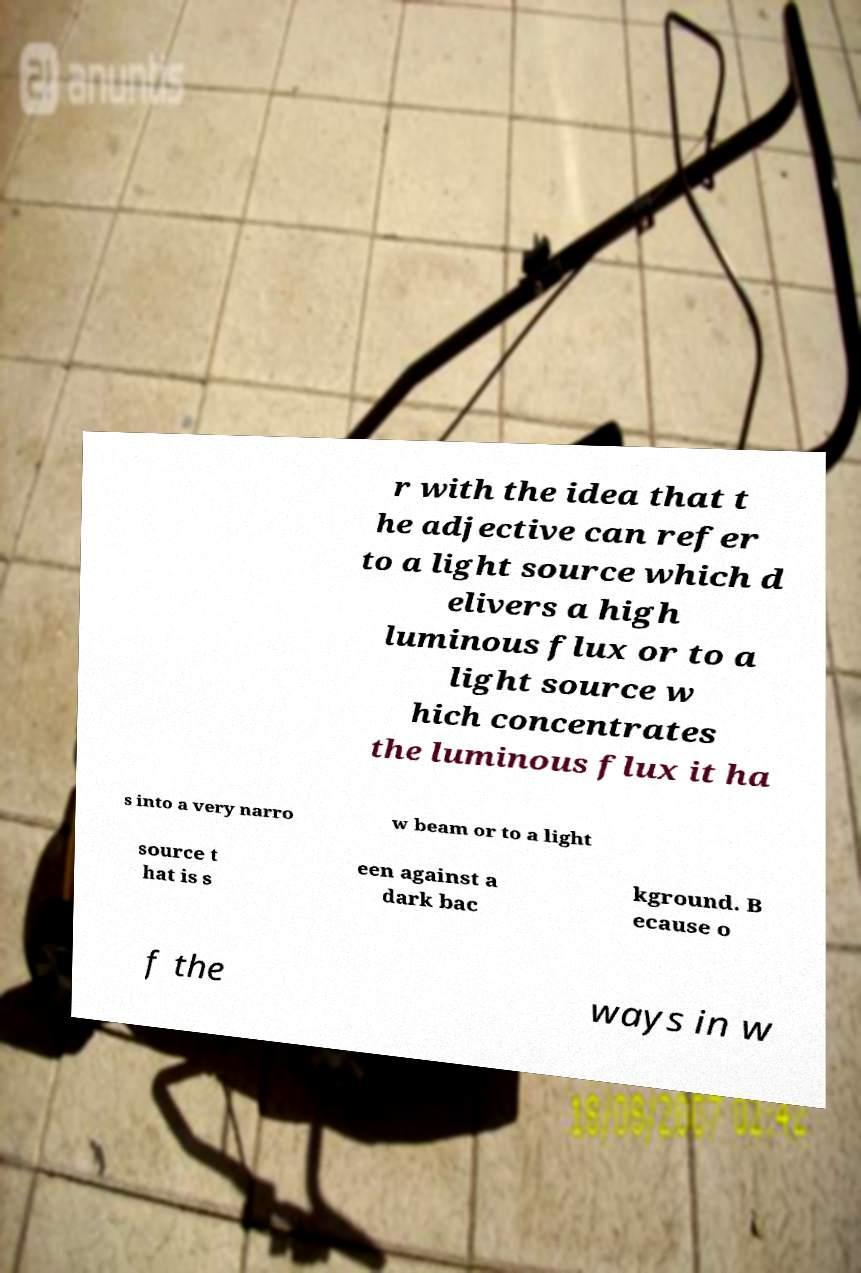Could you assist in decoding the text presented in this image and type it out clearly? r with the idea that t he adjective can refer to a light source which d elivers a high luminous flux or to a light source w hich concentrates the luminous flux it ha s into a very narro w beam or to a light source t hat is s een against a dark bac kground. B ecause o f the ways in w 